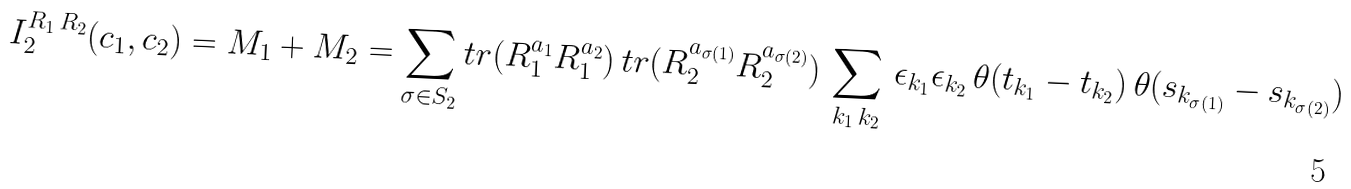Convert formula to latex. <formula><loc_0><loc_0><loc_500><loc_500>I _ { 2 } ^ { R _ { 1 } \, R _ { 2 } } ( c _ { 1 } , c _ { 2 } ) = M _ { 1 } + M _ { 2 } = \sum _ { \sigma \in S _ { 2 } } t r ( R _ { 1 } ^ { a _ { 1 } } R _ { 1 } ^ { a _ { 2 } } ) \, t r ( R _ { 2 } ^ { a _ { \sigma ( 1 ) } } R _ { 2 } ^ { a _ { \sigma ( 2 ) } } ) \, \sum _ { k _ { 1 } \, k _ { 2 } } \, \epsilon _ { k _ { 1 } } \epsilon _ { k _ { 2 } } \, \theta ( t _ { k _ { 1 } } - t _ { k _ { 2 } } ) \, \theta ( s _ { k _ { \sigma ( 1 ) } } - s _ { k _ { \sigma ( 2 ) } } )</formula> 